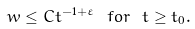<formula> <loc_0><loc_0><loc_500><loc_500>w \leq C t ^ { - 1 + \varepsilon } \ f o r \ t \geq t _ { 0 } .</formula> 